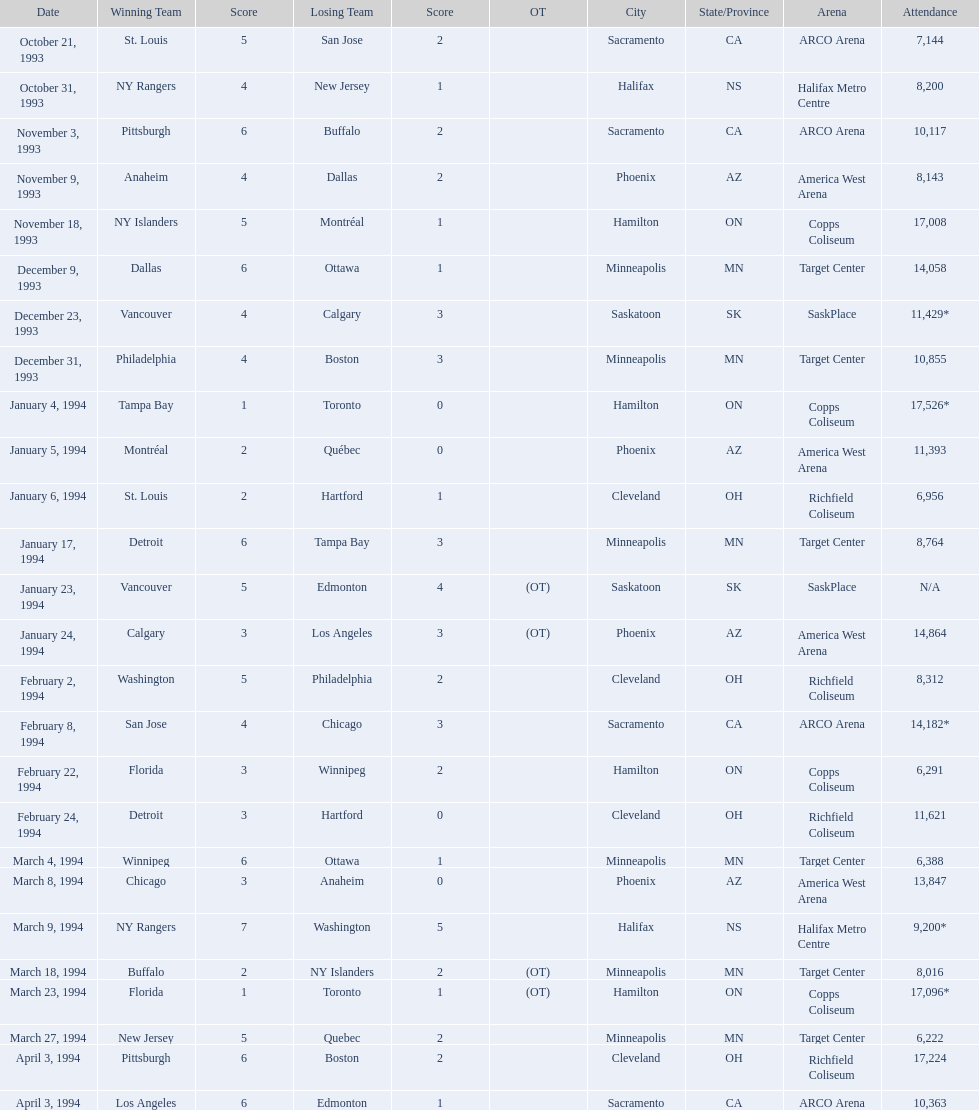Which dates saw the winning team score only one point? January 4, 1994, March 23, 1994. Of these two, which date had higher attendance? January 4, 1994. 